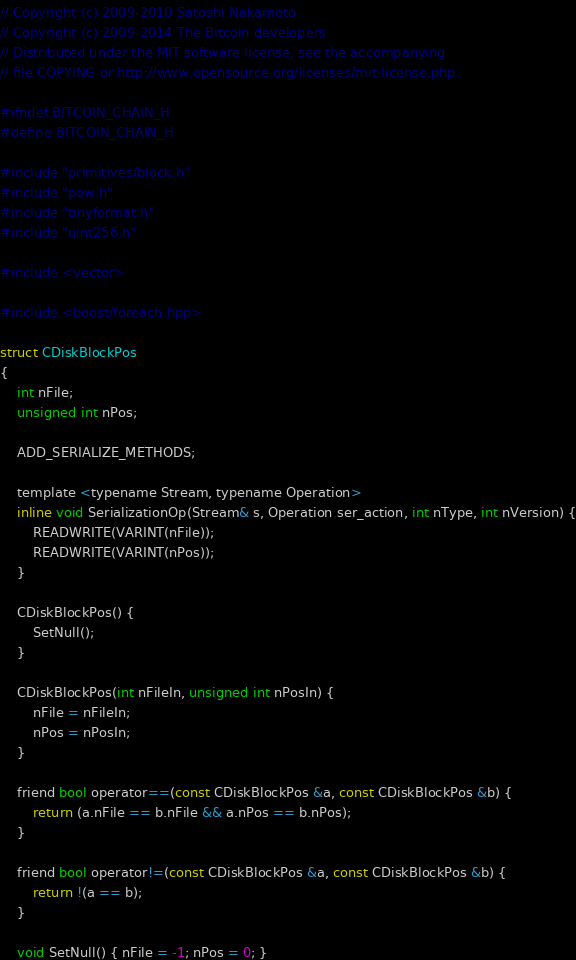<code> <loc_0><loc_0><loc_500><loc_500><_C_>// Copyright (c) 2009-2010 Satoshi Nakamoto
// Copyright (c) 2009-2014 The Bitcoin developers
// Distributed under the MIT software license, see the accompanying
// file COPYING or http://www.opensource.org/licenses/mit-license.php.

#ifndef BITCOIN_CHAIN_H
#define BITCOIN_CHAIN_H

#include "primitives/block.h"
#include "pow.h"
#include "tinyformat.h"
#include "uint256.h"

#include <vector>

#include <boost/foreach.hpp>

struct CDiskBlockPos
{
    int nFile;
    unsigned int nPos;

    ADD_SERIALIZE_METHODS;

    template <typename Stream, typename Operation>
    inline void SerializationOp(Stream& s, Operation ser_action, int nType, int nVersion) {
        READWRITE(VARINT(nFile));
        READWRITE(VARINT(nPos));
    }

    CDiskBlockPos() {
        SetNull();
    }

    CDiskBlockPos(int nFileIn, unsigned int nPosIn) {
        nFile = nFileIn;
        nPos = nPosIn;
    }

    friend bool operator==(const CDiskBlockPos &a, const CDiskBlockPos &b) {
        return (a.nFile == b.nFile && a.nPos == b.nPos);
    }

    friend bool operator!=(const CDiskBlockPos &a, const CDiskBlockPos &b) {
        return !(a == b);
    }

    void SetNull() { nFile = -1; nPos = 0; }</code> 